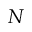Convert formula to latex. <formula><loc_0><loc_0><loc_500><loc_500>N</formula> 